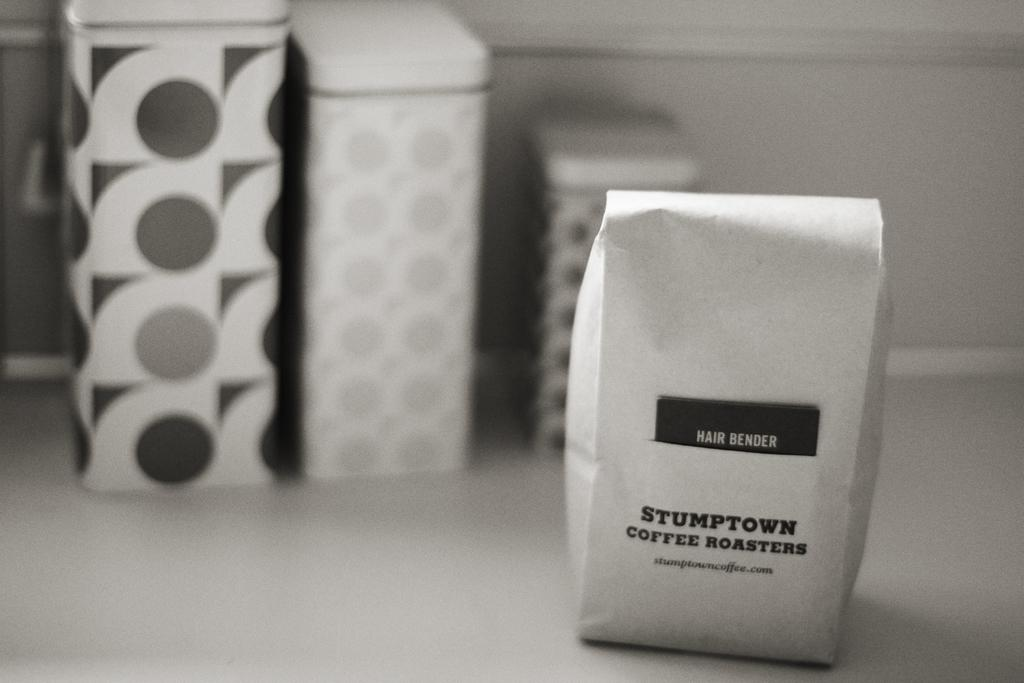Provide a one-sentence caption for the provided image. A black and white image of a bag of Stumptown coffee sitting before three cannisters. 